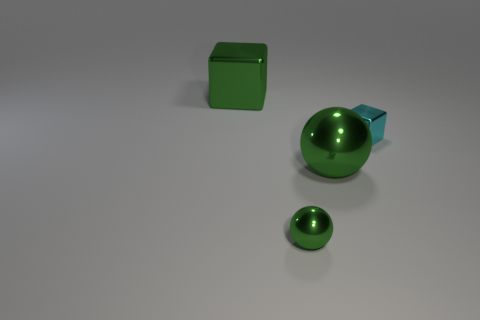Is there any other thing that has the same color as the large shiny block?
Offer a very short reply. Yes. How many large green things are both behind the tiny cyan thing and in front of the small block?
Offer a very short reply. 0. Are there fewer small cubes right of the cyan shiny cube than red metallic things?
Your answer should be compact. No. Is there a cyan thing that has the same size as the cyan cube?
Make the answer very short. No. What color is the tiny object that is made of the same material as the cyan cube?
Your response must be concise. Green. How many small balls are to the right of the tiny metal thing to the left of the cyan cube?
Offer a very short reply. 0. What is the material of the green thing that is in front of the cyan cube and behind the small sphere?
Ensure brevity in your answer.  Metal. There is a metal thing that is behind the tiny block; is its shape the same as the small cyan metal object?
Ensure brevity in your answer.  Yes. Is the number of large green metal balls less than the number of gray metal blocks?
Provide a short and direct response. No. How many metallic balls have the same color as the tiny shiny cube?
Keep it short and to the point. 0. 